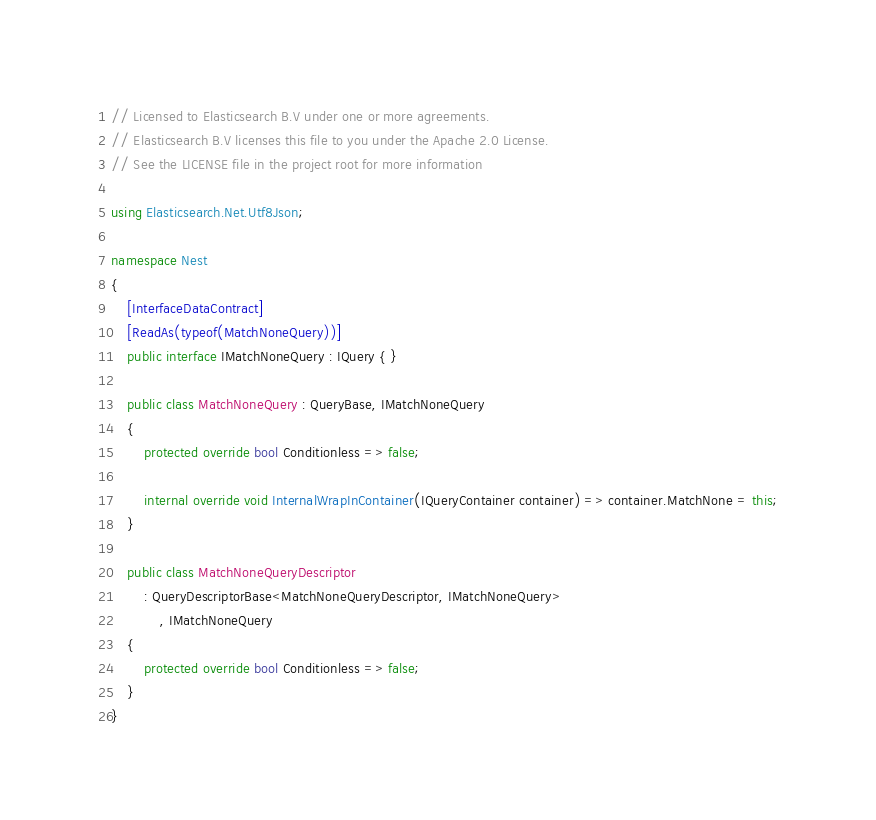<code> <loc_0><loc_0><loc_500><loc_500><_C#_>// Licensed to Elasticsearch B.V under one or more agreements.
// Elasticsearch B.V licenses this file to you under the Apache 2.0 License.
// See the LICENSE file in the project root for more information

using Elasticsearch.Net.Utf8Json;

namespace Nest
{
	[InterfaceDataContract]
	[ReadAs(typeof(MatchNoneQuery))]
	public interface IMatchNoneQuery : IQuery { }

	public class MatchNoneQuery : QueryBase, IMatchNoneQuery
	{
		protected override bool Conditionless => false;

		internal override void InternalWrapInContainer(IQueryContainer container) => container.MatchNone = this;
	}

	public class MatchNoneQueryDescriptor
		: QueryDescriptorBase<MatchNoneQueryDescriptor, IMatchNoneQuery>
			, IMatchNoneQuery
	{
		protected override bool Conditionless => false;
	}
}
</code> 